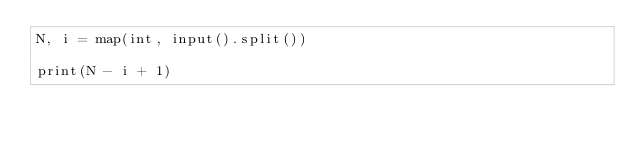<code> <loc_0><loc_0><loc_500><loc_500><_Python_>N, i = map(int, input().split())

print(N - i + 1)
</code> 